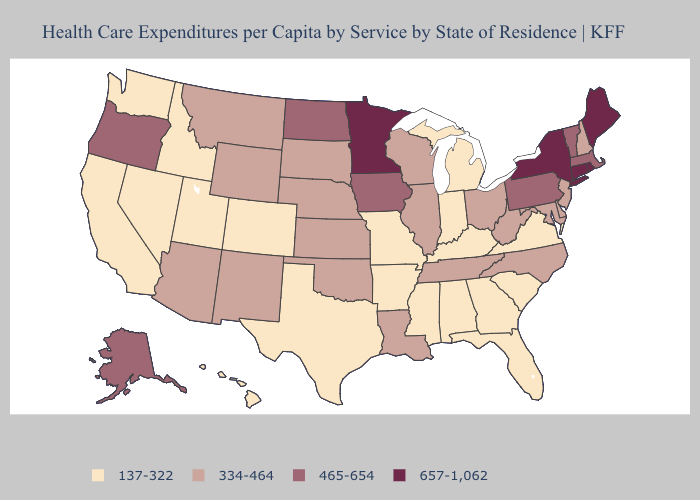Does Massachusetts have the highest value in the Northeast?
Be succinct. No. Name the states that have a value in the range 137-322?
Short answer required. Alabama, Arkansas, California, Colorado, Florida, Georgia, Hawaii, Idaho, Indiana, Kentucky, Michigan, Mississippi, Missouri, Nevada, South Carolina, Texas, Utah, Virginia, Washington. Does Connecticut have a higher value than Colorado?
Concise answer only. Yes. Does New York have the highest value in the Northeast?
Short answer required. Yes. How many symbols are there in the legend?
Short answer required. 4. What is the lowest value in states that border Nevada?
Concise answer only. 137-322. What is the highest value in states that border Kentucky?
Concise answer only. 334-464. What is the value of Maine?
Give a very brief answer. 657-1,062. What is the lowest value in the USA?
Concise answer only. 137-322. What is the value of Wyoming?
Be succinct. 334-464. Name the states that have a value in the range 465-654?
Write a very short answer. Alaska, Iowa, Massachusetts, North Dakota, Oregon, Pennsylvania, Vermont. Does Vermont have a lower value than Connecticut?
Be succinct. Yes. Is the legend a continuous bar?
Give a very brief answer. No. What is the value of Iowa?
Be succinct. 465-654. 